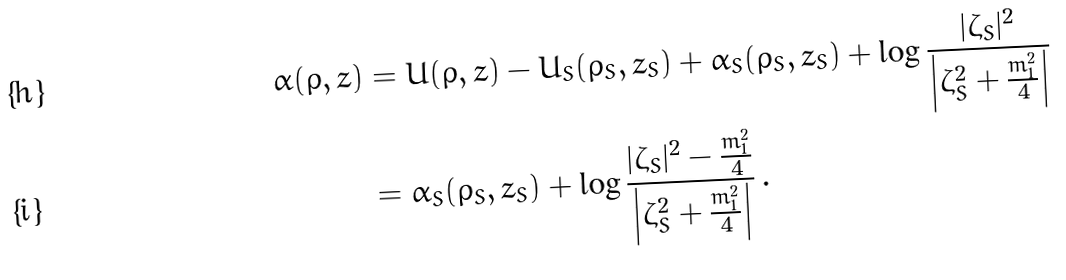Convert formula to latex. <formula><loc_0><loc_0><loc_500><loc_500>\alpha ( \rho , z ) & = U ( \rho , z ) - U _ { S } ( \rho _ { S } , z _ { S } ) + \alpha _ { S } ( \rho _ { S } , z _ { S } ) + \log \frac { | \zeta _ { S } | ^ { 2 } } { \left | \zeta _ { S } ^ { 2 } + \frac { m _ { 1 } ^ { 2 } } { 4 } \right | } \\ & = \alpha _ { S } ( \rho _ { S } , z _ { S } ) + \log \frac { | \zeta _ { S } | ^ { 2 } - \frac { m _ { 1 } ^ { 2 } } { 4 } } { \left | \zeta _ { S } ^ { 2 } + \frac { m _ { 1 } ^ { 2 } } { 4 } \right | } \, .</formula> 